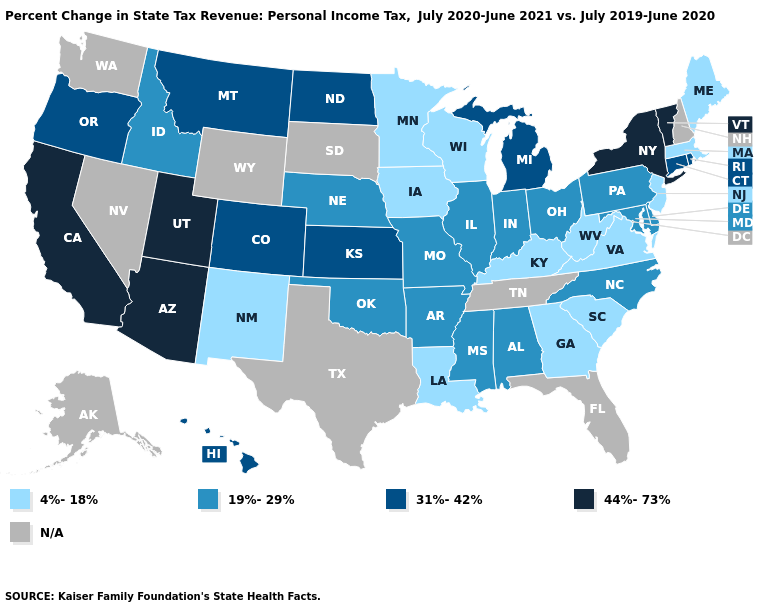What is the lowest value in states that border West Virginia?
Be succinct. 4%-18%. Does Kentucky have the highest value in the South?
Quick response, please. No. What is the value of North Dakota?
Answer briefly. 31%-42%. Among the states that border North Dakota , does Minnesota have the highest value?
Be succinct. No. Name the states that have a value in the range N/A?
Keep it brief. Alaska, Florida, Nevada, New Hampshire, South Dakota, Tennessee, Texas, Washington, Wyoming. Does the map have missing data?
Short answer required. Yes. Which states hav the highest value in the South?
Keep it brief. Alabama, Arkansas, Delaware, Maryland, Mississippi, North Carolina, Oklahoma. Name the states that have a value in the range 19%-29%?
Give a very brief answer. Alabama, Arkansas, Delaware, Idaho, Illinois, Indiana, Maryland, Mississippi, Missouri, Nebraska, North Carolina, Ohio, Oklahoma, Pennsylvania. What is the value of Oregon?
Write a very short answer. 31%-42%. What is the lowest value in states that border Nevada?
Quick response, please. 19%-29%. What is the value of Rhode Island?
Short answer required. 31%-42%. Does California have the highest value in the USA?
Give a very brief answer. Yes. Does Illinois have the lowest value in the USA?
Short answer required. No. Does North Carolina have the highest value in the USA?
Short answer required. No. Among the states that border Mississippi , which have the highest value?
Concise answer only. Alabama, Arkansas. 